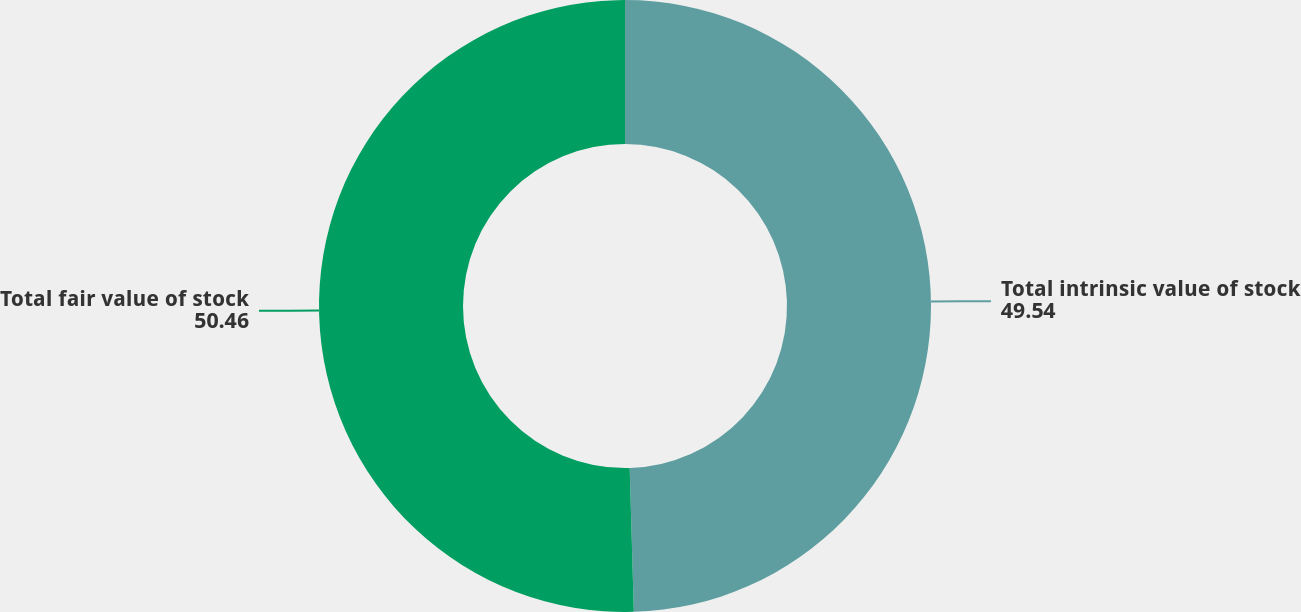<chart> <loc_0><loc_0><loc_500><loc_500><pie_chart><fcel>Total intrinsic value of stock<fcel>Total fair value of stock<nl><fcel>49.54%<fcel>50.46%<nl></chart> 